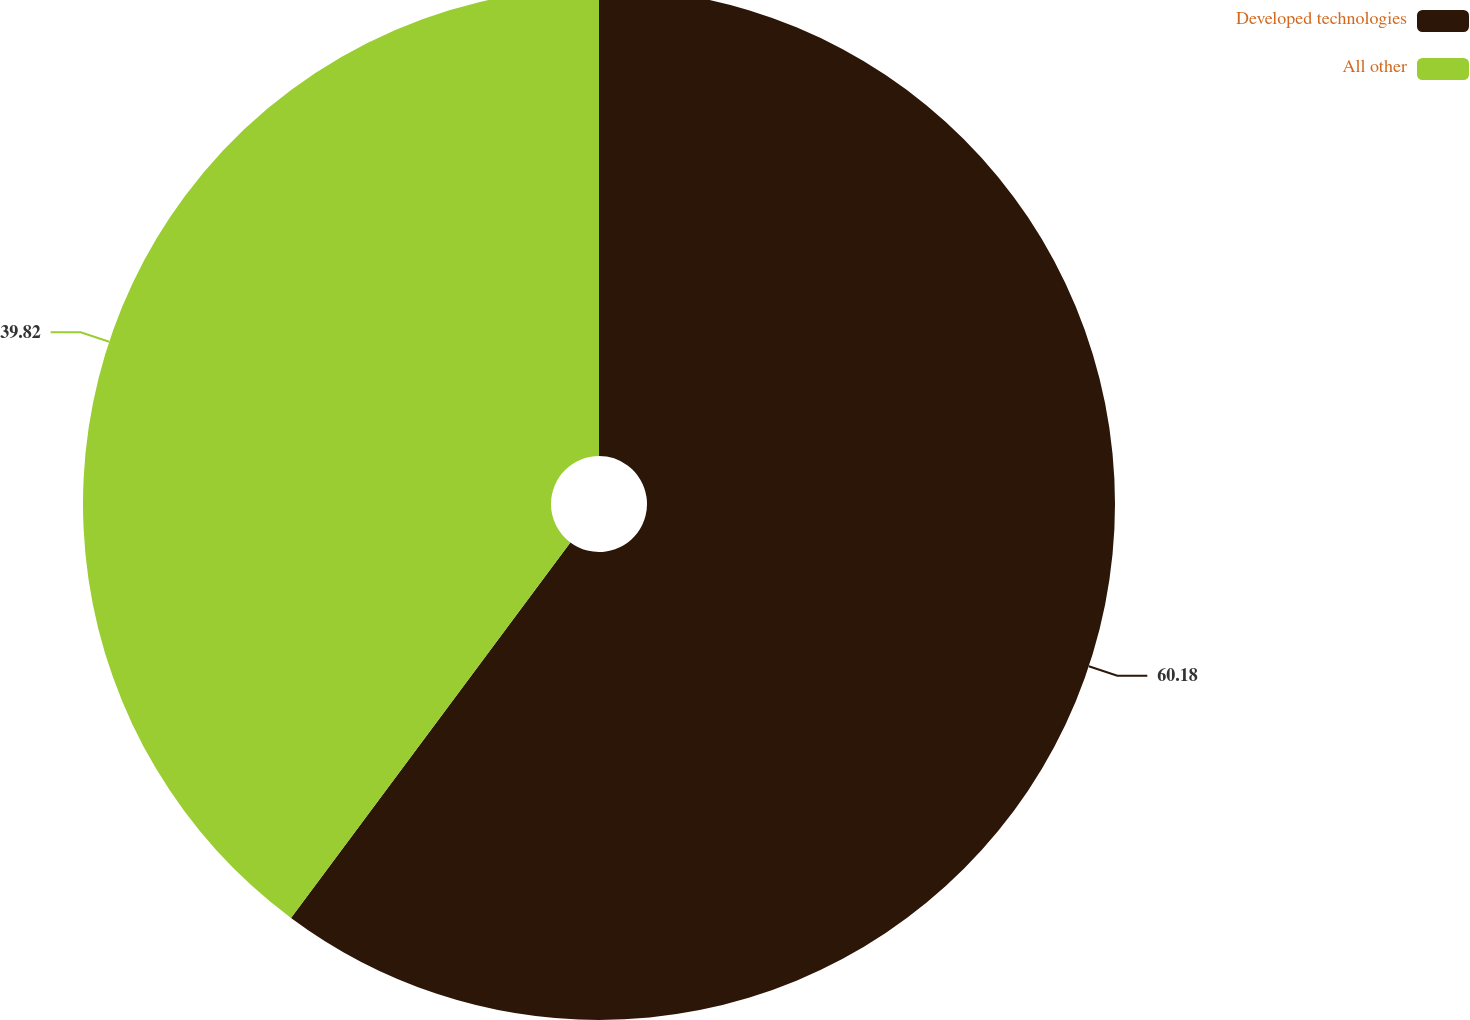Convert chart. <chart><loc_0><loc_0><loc_500><loc_500><pie_chart><fcel>Developed technologies<fcel>All other<nl><fcel>60.18%<fcel>39.82%<nl></chart> 